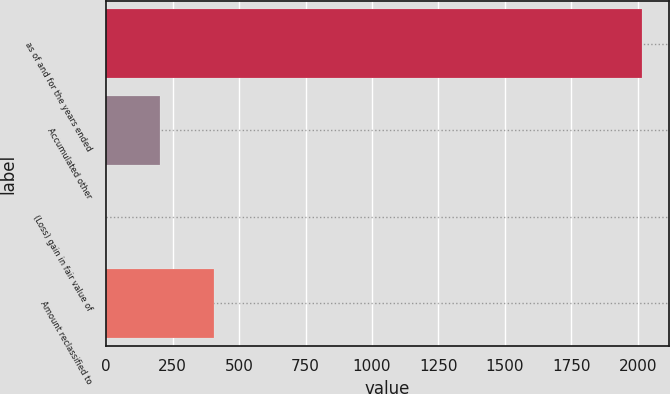Convert chart. <chart><loc_0><loc_0><loc_500><loc_500><bar_chart><fcel>as of and for the years ended<fcel>Accumulated other<fcel>(Loss) gain in fair value of<fcel>Amount reclassified to<nl><fcel>2016<fcel>202.5<fcel>1<fcel>404<nl></chart> 